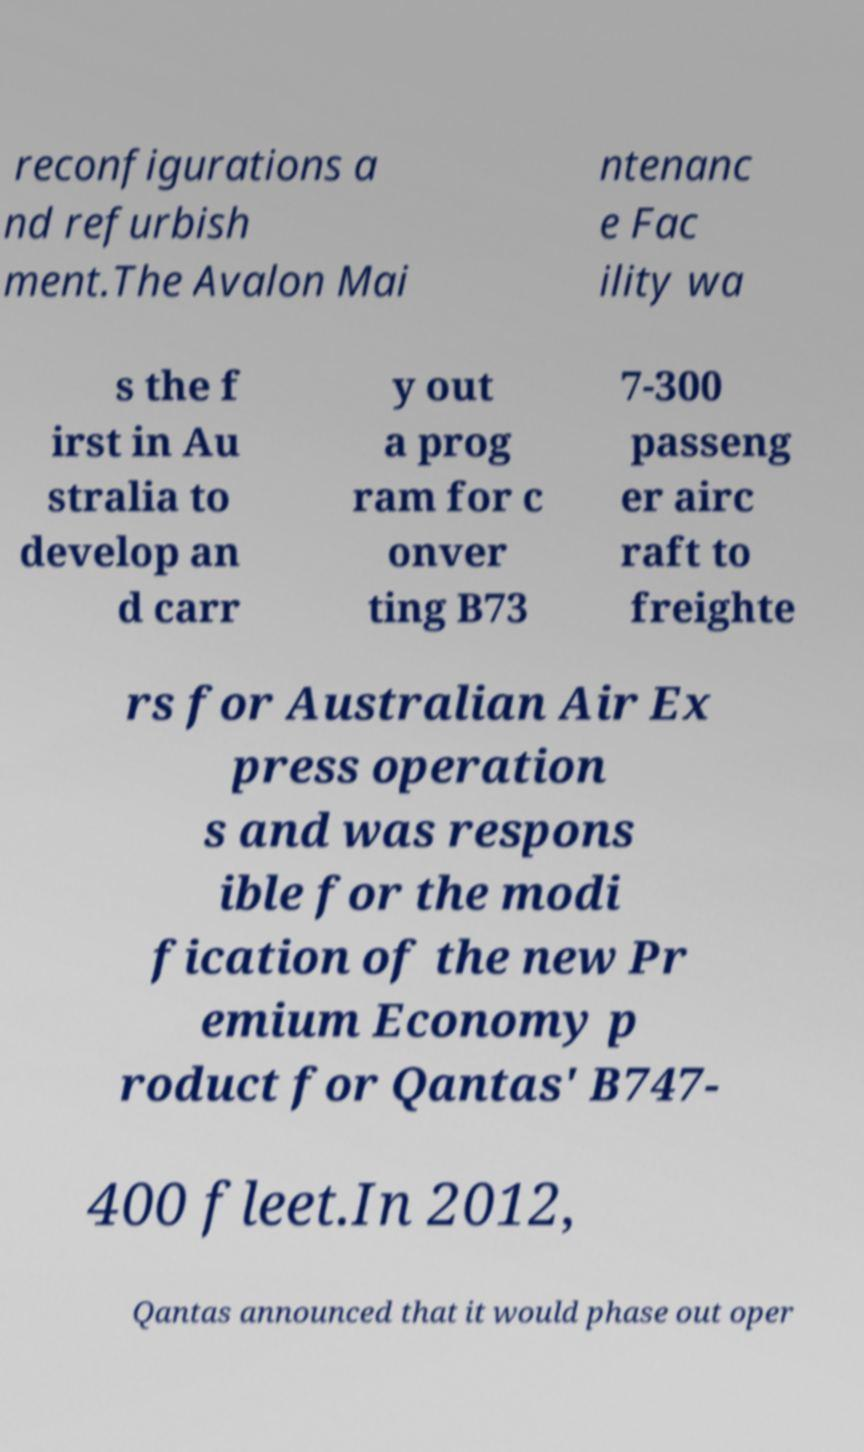For documentation purposes, I need the text within this image transcribed. Could you provide that? reconfigurations a nd refurbish ment.The Avalon Mai ntenanc e Fac ility wa s the f irst in Au stralia to develop an d carr y out a prog ram for c onver ting B73 7-300 passeng er airc raft to freighte rs for Australian Air Ex press operation s and was respons ible for the modi fication of the new Pr emium Economy p roduct for Qantas' B747- 400 fleet.In 2012, Qantas announced that it would phase out oper 